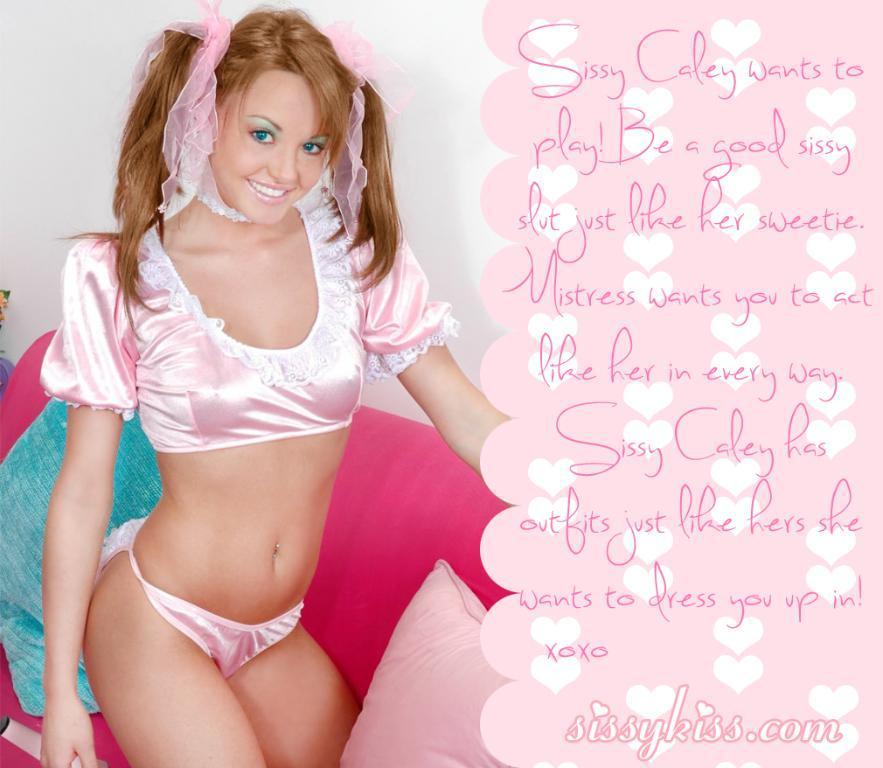Describe this image in one or two sentences. In this picture we can see a woman in the squat position on the couch and on the couch there are cushions. Behind the woman there is a wall and on the image it is written something. 